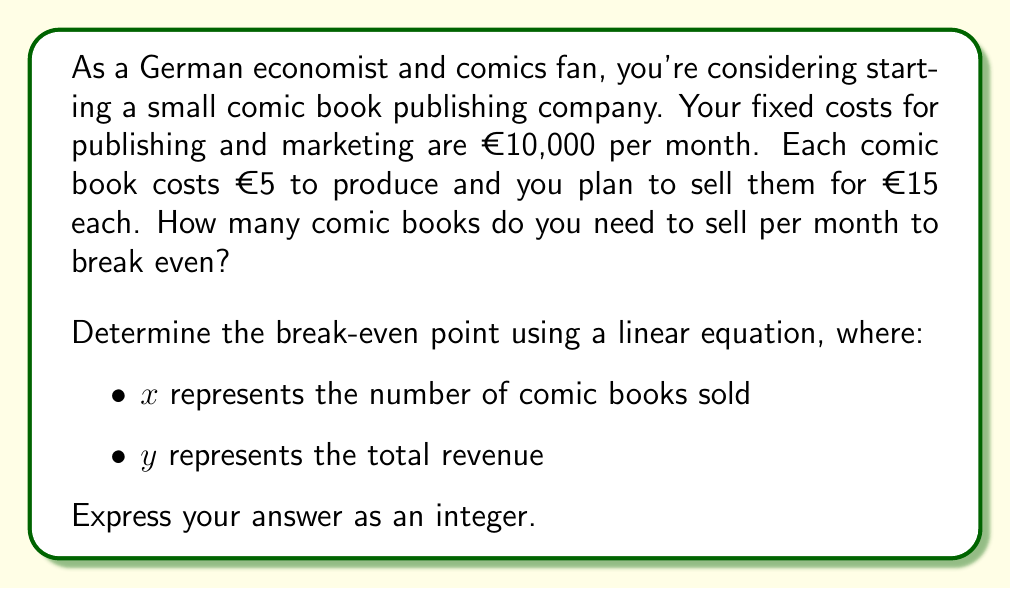Give your solution to this math problem. To solve this problem, we'll use the break-even analysis method with linear equations. Let's break it down step-by-step:

1) First, let's define our variables:
   - Fixed costs (FC) = €10,000
   - Price per comic (P) = €15
   - Variable cost per comic (VC) = €5

2) The linear equation for total revenue (TR) is:
   $$ TR = Px $$

3) The linear equation for total costs (TC) is:
   $$ TC = FC + VCx $$

4) At the break-even point, total revenue equals total costs:
   $$ TR = TC $$
   $$ Px = FC + VCx $$

5) Let's substitute our known values:
   $$ 15x = 10,000 + 5x $$

6) Solve for x:
   $$ 15x - 5x = 10,000 $$
   $$ 10x = 10,000 $$
   $$ x = 1,000 $$

Therefore, you need to sell 1,000 comic books to break even.

To verify:
- Revenue: 1,000 * €15 = €15,000
- Costs: €10,000 + (1,000 * €5) = €15,000

Indeed, at 1,000 units, revenue equals costs.
Answer: 1,000 comic books 